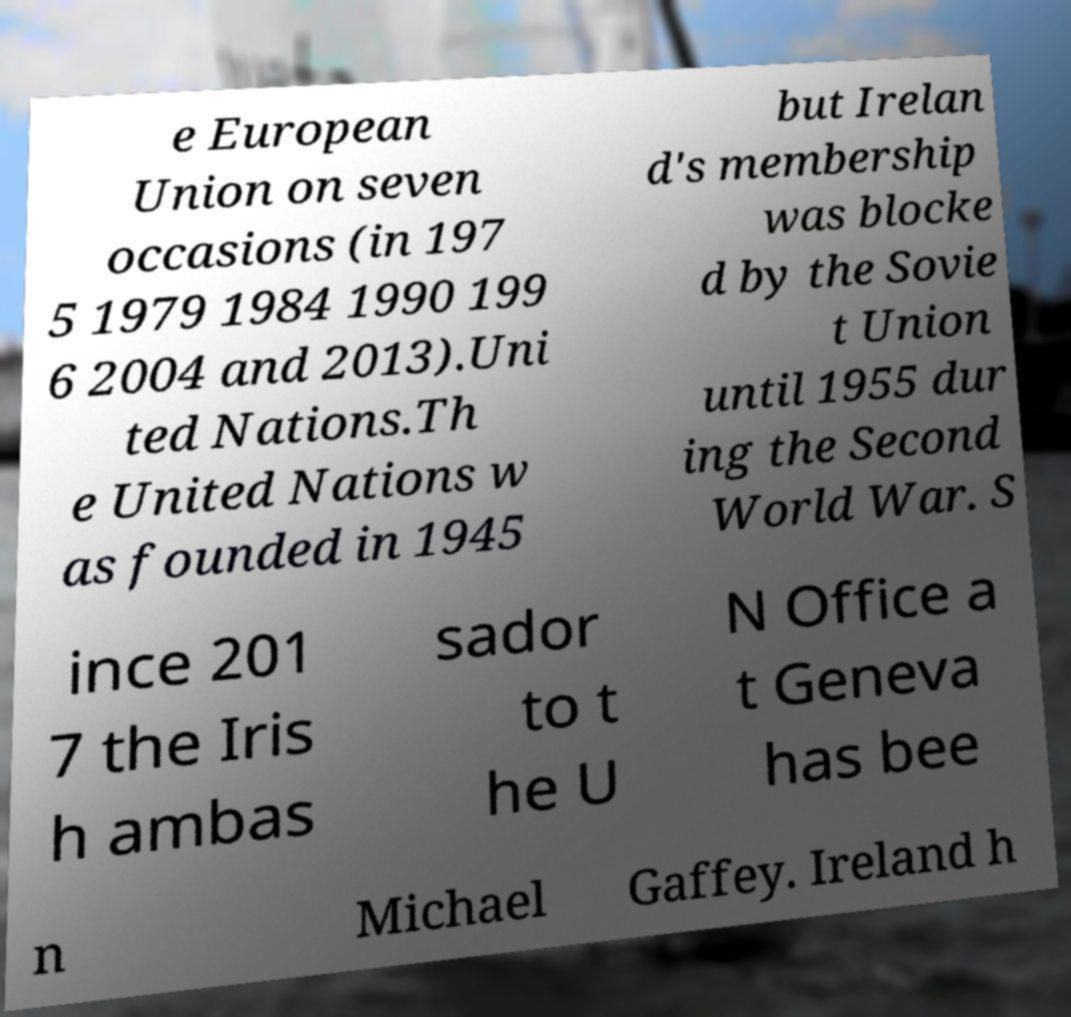Please read and relay the text visible in this image. What does it say? e European Union on seven occasions (in 197 5 1979 1984 1990 199 6 2004 and 2013).Uni ted Nations.Th e United Nations w as founded in 1945 but Irelan d's membership was blocke d by the Sovie t Union until 1955 dur ing the Second World War. S ince 201 7 the Iris h ambas sador to t he U N Office a t Geneva has bee n Michael Gaffey. Ireland h 